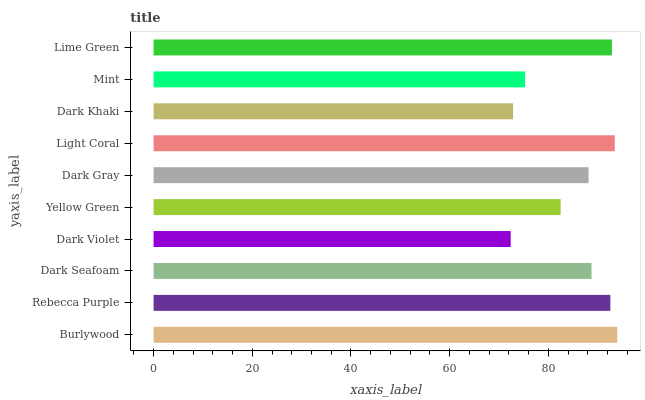Is Dark Violet the minimum?
Answer yes or no. Yes. Is Burlywood the maximum?
Answer yes or no. Yes. Is Rebecca Purple the minimum?
Answer yes or no. No. Is Rebecca Purple the maximum?
Answer yes or no. No. Is Burlywood greater than Rebecca Purple?
Answer yes or no. Yes. Is Rebecca Purple less than Burlywood?
Answer yes or no. Yes. Is Rebecca Purple greater than Burlywood?
Answer yes or no. No. Is Burlywood less than Rebecca Purple?
Answer yes or no. No. Is Dark Seafoam the high median?
Answer yes or no. Yes. Is Dark Gray the low median?
Answer yes or no. Yes. Is Mint the high median?
Answer yes or no. No. Is Dark Violet the low median?
Answer yes or no. No. 